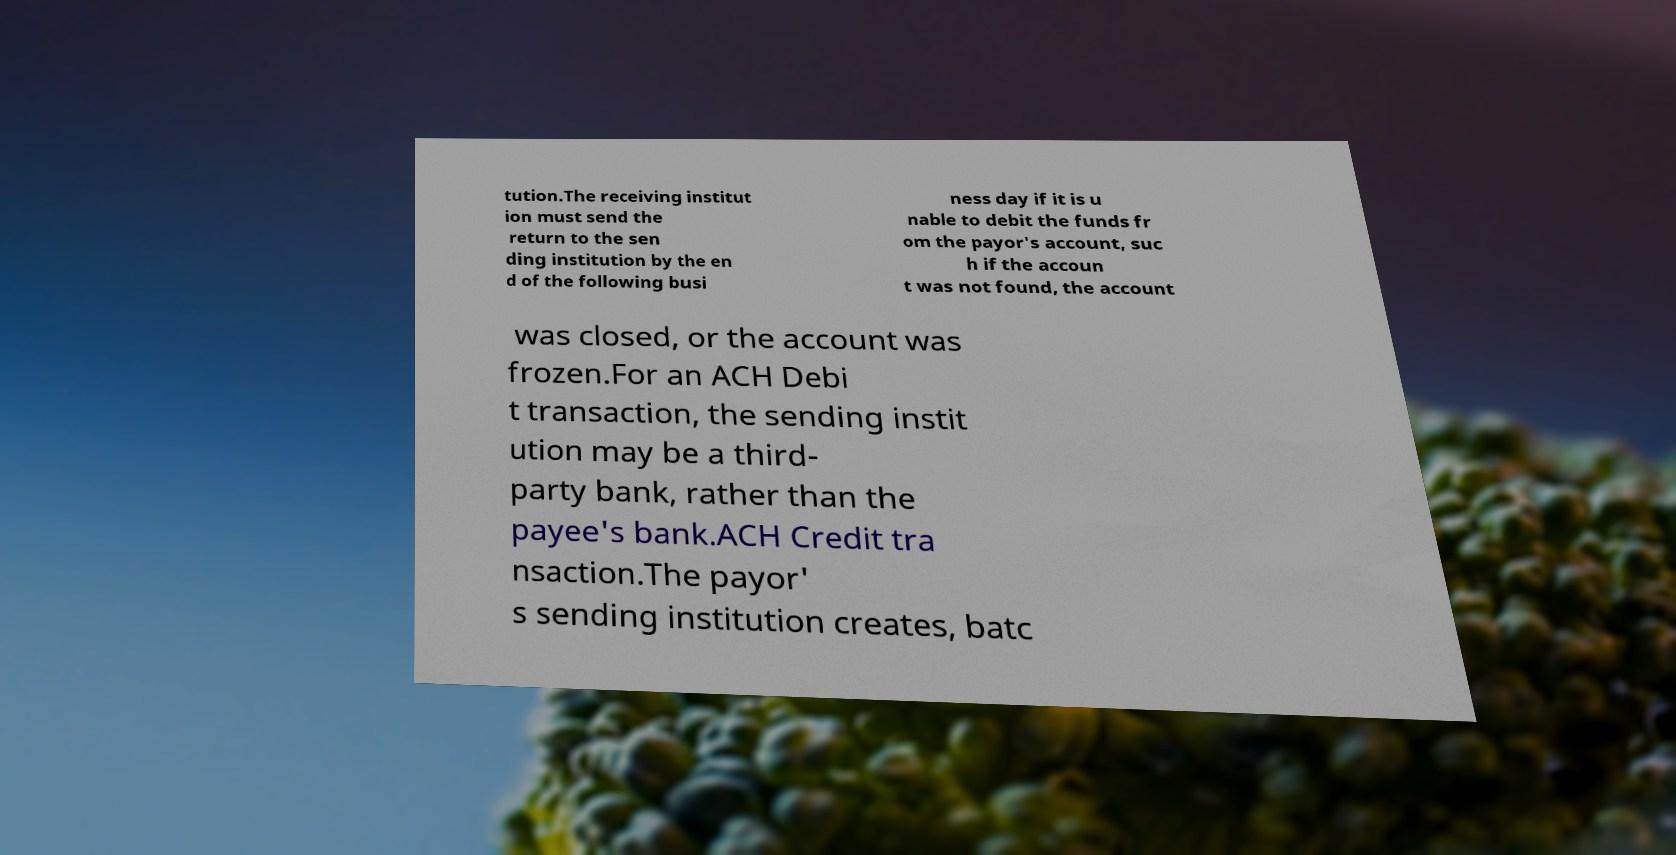There's text embedded in this image that I need extracted. Can you transcribe it verbatim? tution.The receiving institut ion must send the return to the sen ding institution by the en d of the following busi ness day if it is u nable to debit the funds fr om the payor's account, suc h if the accoun t was not found, the account was closed, or the account was frozen.For an ACH Debi t transaction, the sending instit ution may be a third- party bank, rather than the payee's bank.ACH Credit tra nsaction.The payor' s sending institution creates, batc 